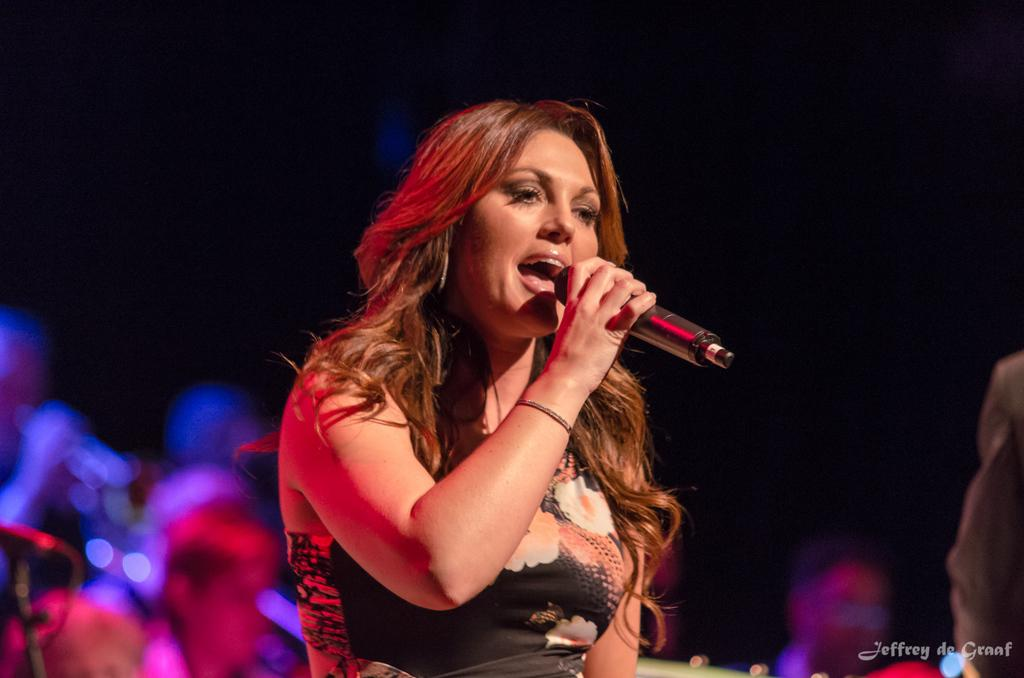What is the gender of the person in the image? There is a lady person in the image. What is the lady person wearing? The lady person is wearing a black dress. What is the lady person holding in the image? The lady person is holding a microphone. What can be seen in the background of the image? There is a dark black color sheet and spectators in the background of the image. What type of leaf is being used as a prop by the lady person in the image? There is no leaf present in the image; the lady person is holding a microphone. 